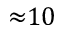Convert formula to latex. <formula><loc_0><loc_0><loc_500><loc_500>{ \approx } 1 0</formula> 